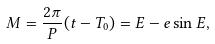Convert formula to latex. <formula><loc_0><loc_0><loc_500><loc_500>M = \frac { 2 \pi } { P } ( t - T _ { 0 } ) = E - e \sin E ,</formula> 